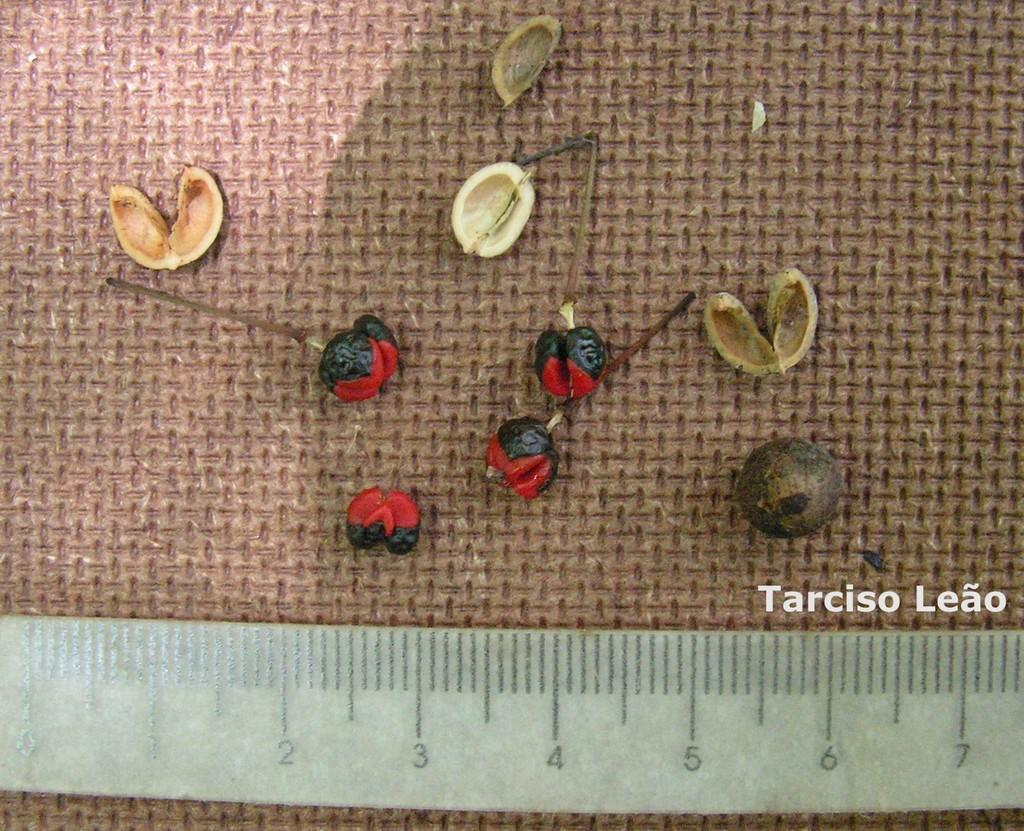<image>
Create a compact narrative representing the image presented. Ruler for 7 inches measuring some shells and round things 